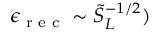Convert formula to latex. <formula><loc_0><loc_0><loc_500><loc_500>\epsilon _ { r e c } \sim \tilde { S } _ { L } ^ { - 1 / 2 } )</formula> 